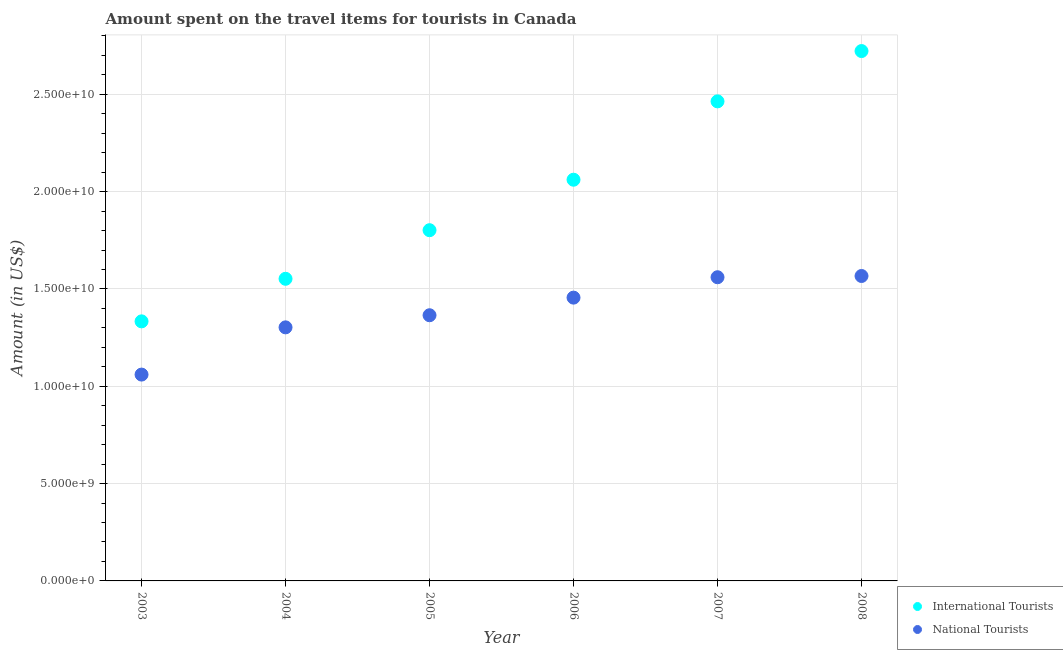How many different coloured dotlines are there?
Your response must be concise. 2. Is the number of dotlines equal to the number of legend labels?
Your answer should be very brief. Yes. What is the amount spent on travel items of national tourists in 2006?
Give a very brief answer. 1.46e+1. Across all years, what is the maximum amount spent on travel items of international tourists?
Your response must be concise. 2.72e+1. Across all years, what is the minimum amount spent on travel items of national tourists?
Your answer should be very brief. 1.06e+1. In which year was the amount spent on travel items of national tourists maximum?
Your response must be concise. 2008. What is the total amount spent on travel items of national tourists in the graph?
Offer a very short reply. 8.31e+1. What is the difference between the amount spent on travel items of national tourists in 2003 and that in 2008?
Offer a terse response. -5.07e+09. What is the difference between the amount spent on travel items of international tourists in 2007 and the amount spent on travel items of national tourists in 2008?
Give a very brief answer. 8.97e+09. What is the average amount spent on travel items of international tourists per year?
Offer a terse response. 1.99e+1. In the year 2003, what is the difference between the amount spent on travel items of national tourists and amount spent on travel items of international tourists?
Ensure brevity in your answer.  -2.74e+09. What is the ratio of the amount spent on travel items of international tourists in 2005 to that in 2006?
Your response must be concise. 0.87. Is the amount spent on travel items of national tourists in 2006 less than that in 2007?
Offer a terse response. Yes. What is the difference between the highest and the second highest amount spent on travel items of national tourists?
Give a very brief answer. 6.40e+07. What is the difference between the highest and the lowest amount spent on travel items of international tourists?
Give a very brief answer. 1.39e+1. In how many years, is the amount spent on travel items of national tourists greater than the average amount spent on travel items of national tourists taken over all years?
Your response must be concise. 3. Is the sum of the amount spent on travel items of international tourists in 2005 and 2008 greater than the maximum amount spent on travel items of national tourists across all years?
Make the answer very short. Yes. Is the amount spent on travel items of national tourists strictly less than the amount spent on travel items of international tourists over the years?
Give a very brief answer. Yes. How many years are there in the graph?
Make the answer very short. 6. Where does the legend appear in the graph?
Ensure brevity in your answer.  Bottom right. How many legend labels are there?
Your answer should be very brief. 2. What is the title of the graph?
Provide a short and direct response. Amount spent on the travel items for tourists in Canada. What is the Amount (in US$) in International Tourists in 2003?
Provide a succinct answer. 1.33e+1. What is the Amount (in US$) of National Tourists in 2003?
Offer a terse response. 1.06e+1. What is the Amount (in US$) in International Tourists in 2004?
Give a very brief answer. 1.55e+1. What is the Amount (in US$) in National Tourists in 2004?
Give a very brief answer. 1.30e+1. What is the Amount (in US$) in International Tourists in 2005?
Keep it short and to the point. 1.80e+1. What is the Amount (in US$) of National Tourists in 2005?
Provide a succinct answer. 1.37e+1. What is the Amount (in US$) in International Tourists in 2006?
Provide a succinct answer. 2.06e+1. What is the Amount (in US$) in National Tourists in 2006?
Your answer should be compact. 1.46e+1. What is the Amount (in US$) in International Tourists in 2007?
Your answer should be very brief. 2.46e+1. What is the Amount (in US$) in National Tourists in 2007?
Ensure brevity in your answer.  1.56e+1. What is the Amount (in US$) in International Tourists in 2008?
Your answer should be very brief. 2.72e+1. What is the Amount (in US$) in National Tourists in 2008?
Make the answer very short. 1.57e+1. Across all years, what is the maximum Amount (in US$) in International Tourists?
Provide a short and direct response. 2.72e+1. Across all years, what is the maximum Amount (in US$) in National Tourists?
Give a very brief answer. 1.57e+1. Across all years, what is the minimum Amount (in US$) of International Tourists?
Ensure brevity in your answer.  1.33e+1. Across all years, what is the minimum Amount (in US$) of National Tourists?
Provide a short and direct response. 1.06e+1. What is the total Amount (in US$) of International Tourists in the graph?
Keep it short and to the point. 1.19e+11. What is the total Amount (in US$) of National Tourists in the graph?
Your answer should be compact. 8.31e+1. What is the difference between the Amount (in US$) of International Tourists in 2003 and that in 2004?
Ensure brevity in your answer.  -2.19e+09. What is the difference between the Amount (in US$) of National Tourists in 2003 and that in 2004?
Provide a short and direct response. -2.43e+09. What is the difference between the Amount (in US$) in International Tourists in 2003 and that in 2005?
Your answer should be very brief. -4.68e+09. What is the difference between the Amount (in US$) in National Tourists in 2003 and that in 2005?
Make the answer very short. -3.05e+09. What is the difference between the Amount (in US$) in International Tourists in 2003 and that in 2006?
Offer a very short reply. -7.28e+09. What is the difference between the Amount (in US$) in National Tourists in 2003 and that in 2006?
Offer a very short reply. -3.95e+09. What is the difference between the Amount (in US$) in International Tourists in 2003 and that in 2007?
Offer a very short reply. -1.13e+1. What is the difference between the Amount (in US$) in National Tourists in 2003 and that in 2007?
Offer a terse response. -5.00e+09. What is the difference between the Amount (in US$) in International Tourists in 2003 and that in 2008?
Offer a terse response. -1.39e+1. What is the difference between the Amount (in US$) of National Tourists in 2003 and that in 2008?
Your response must be concise. -5.07e+09. What is the difference between the Amount (in US$) of International Tourists in 2004 and that in 2005?
Your response must be concise. -2.50e+09. What is the difference between the Amount (in US$) in National Tourists in 2004 and that in 2005?
Your response must be concise. -6.22e+08. What is the difference between the Amount (in US$) of International Tourists in 2004 and that in 2006?
Ensure brevity in your answer.  -5.09e+09. What is the difference between the Amount (in US$) in National Tourists in 2004 and that in 2006?
Keep it short and to the point. -1.53e+09. What is the difference between the Amount (in US$) in International Tourists in 2004 and that in 2007?
Your answer should be compact. -9.12e+09. What is the difference between the Amount (in US$) of National Tourists in 2004 and that in 2007?
Your answer should be very brief. -2.58e+09. What is the difference between the Amount (in US$) in International Tourists in 2004 and that in 2008?
Your answer should be very brief. -1.17e+1. What is the difference between the Amount (in US$) in National Tourists in 2004 and that in 2008?
Provide a succinct answer. -2.64e+09. What is the difference between the Amount (in US$) of International Tourists in 2005 and that in 2006?
Your response must be concise. -2.59e+09. What is the difference between the Amount (in US$) in National Tourists in 2005 and that in 2006?
Offer a terse response. -9.05e+08. What is the difference between the Amount (in US$) of International Tourists in 2005 and that in 2007?
Provide a succinct answer. -6.62e+09. What is the difference between the Amount (in US$) of National Tourists in 2005 and that in 2007?
Provide a short and direct response. -1.95e+09. What is the difference between the Amount (in US$) in International Tourists in 2005 and that in 2008?
Offer a very short reply. -9.20e+09. What is the difference between the Amount (in US$) in National Tourists in 2005 and that in 2008?
Your answer should be very brief. -2.02e+09. What is the difference between the Amount (in US$) of International Tourists in 2006 and that in 2007?
Your answer should be very brief. -4.03e+09. What is the difference between the Amount (in US$) of National Tourists in 2006 and that in 2007?
Your answer should be very brief. -1.05e+09. What is the difference between the Amount (in US$) of International Tourists in 2006 and that in 2008?
Your answer should be compact. -6.61e+09. What is the difference between the Amount (in US$) in National Tourists in 2006 and that in 2008?
Your answer should be compact. -1.11e+09. What is the difference between the Amount (in US$) in International Tourists in 2007 and that in 2008?
Offer a very short reply. -2.58e+09. What is the difference between the Amount (in US$) of National Tourists in 2007 and that in 2008?
Provide a short and direct response. -6.40e+07. What is the difference between the Amount (in US$) in International Tourists in 2003 and the Amount (in US$) in National Tourists in 2004?
Offer a very short reply. 3.08e+08. What is the difference between the Amount (in US$) in International Tourists in 2003 and the Amount (in US$) in National Tourists in 2005?
Provide a short and direct response. -3.14e+08. What is the difference between the Amount (in US$) in International Tourists in 2003 and the Amount (in US$) in National Tourists in 2006?
Offer a very short reply. -1.22e+09. What is the difference between the Amount (in US$) in International Tourists in 2003 and the Amount (in US$) in National Tourists in 2007?
Offer a terse response. -2.27e+09. What is the difference between the Amount (in US$) of International Tourists in 2003 and the Amount (in US$) of National Tourists in 2008?
Offer a terse response. -2.33e+09. What is the difference between the Amount (in US$) of International Tourists in 2004 and the Amount (in US$) of National Tourists in 2005?
Your answer should be very brief. 1.87e+09. What is the difference between the Amount (in US$) of International Tourists in 2004 and the Amount (in US$) of National Tourists in 2006?
Your response must be concise. 9.68e+08. What is the difference between the Amount (in US$) in International Tourists in 2004 and the Amount (in US$) in National Tourists in 2007?
Keep it short and to the point. -8.00e+07. What is the difference between the Amount (in US$) of International Tourists in 2004 and the Amount (in US$) of National Tourists in 2008?
Keep it short and to the point. -1.44e+08. What is the difference between the Amount (in US$) of International Tourists in 2005 and the Amount (in US$) of National Tourists in 2006?
Make the answer very short. 3.46e+09. What is the difference between the Amount (in US$) of International Tourists in 2005 and the Amount (in US$) of National Tourists in 2007?
Make the answer very short. 2.42e+09. What is the difference between the Amount (in US$) in International Tourists in 2005 and the Amount (in US$) in National Tourists in 2008?
Ensure brevity in your answer.  2.35e+09. What is the difference between the Amount (in US$) in International Tourists in 2006 and the Amount (in US$) in National Tourists in 2007?
Provide a succinct answer. 5.01e+09. What is the difference between the Amount (in US$) of International Tourists in 2006 and the Amount (in US$) of National Tourists in 2008?
Ensure brevity in your answer.  4.95e+09. What is the difference between the Amount (in US$) in International Tourists in 2007 and the Amount (in US$) in National Tourists in 2008?
Ensure brevity in your answer.  8.97e+09. What is the average Amount (in US$) of International Tourists per year?
Give a very brief answer. 1.99e+1. What is the average Amount (in US$) in National Tourists per year?
Your answer should be very brief. 1.39e+1. In the year 2003, what is the difference between the Amount (in US$) of International Tourists and Amount (in US$) of National Tourists?
Offer a very short reply. 2.74e+09. In the year 2004, what is the difference between the Amount (in US$) of International Tourists and Amount (in US$) of National Tourists?
Your response must be concise. 2.50e+09. In the year 2005, what is the difference between the Amount (in US$) in International Tourists and Amount (in US$) in National Tourists?
Provide a succinct answer. 4.37e+09. In the year 2006, what is the difference between the Amount (in US$) of International Tourists and Amount (in US$) of National Tourists?
Offer a terse response. 6.06e+09. In the year 2007, what is the difference between the Amount (in US$) in International Tourists and Amount (in US$) in National Tourists?
Your answer should be compact. 9.04e+09. In the year 2008, what is the difference between the Amount (in US$) in International Tourists and Amount (in US$) in National Tourists?
Make the answer very short. 1.16e+1. What is the ratio of the Amount (in US$) of International Tourists in 2003 to that in 2004?
Offer a terse response. 0.86. What is the ratio of the Amount (in US$) in National Tourists in 2003 to that in 2004?
Offer a very short reply. 0.81. What is the ratio of the Amount (in US$) in International Tourists in 2003 to that in 2005?
Keep it short and to the point. 0.74. What is the ratio of the Amount (in US$) of National Tourists in 2003 to that in 2005?
Your response must be concise. 0.78. What is the ratio of the Amount (in US$) in International Tourists in 2003 to that in 2006?
Keep it short and to the point. 0.65. What is the ratio of the Amount (in US$) of National Tourists in 2003 to that in 2006?
Make the answer very short. 0.73. What is the ratio of the Amount (in US$) in International Tourists in 2003 to that in 2007?
Keep it short and to the point. 0.54. What is the ratio of the Amount (in US$) in National Tourists in 2003 to that in 2007?
Your response must be concise. 0.68. What is the ratio of the Amount (in US$) of International Tourists in 2003 to that in 2008?
Offer a terse response. 0.49. What is the ratio of the Amount (in US$) of National Tourists in 2003 to that in 2008?
Offer a very short reply. 0.68. What is the ratio of the Amount (in US$) of International Tourists in 2004 to that in 2005?
Ensure brevity in your answer.  0.86. What is the ratio of the Amount (in US$) of National Tourists in 2004 to that in 2005?
Your response must be concise. 0.95. What is the ratio of the Amount (in US$) in International Tourists in 2004 to that in 2006?
Give a very brief answer. 0.75. What is the ratio of the Amount (in US$) of National Tourists in 2004 to that in 2006?
Your answer should be very brief. 0.9. What is the ratio of the Amount (in US$) in International Tourists in 2004 to that in 2007?
Offer a terse response. 0.63. What is the ratio of the Amount (in US$) in National Tourists in 2004 to that in 2007?
Provide a short and direct response. 0.83. What is the ratio of the Amount (in US$) of International Tourists in 2004 to that in 2008?
Give a very brief answer. 0.57. What is the ratio of the Amount (in US$) of National Tourists in 2004 to that in 2008?
Your answer should be compact. 0.83. What is the ratio of the Amount (in US$) in International Tourists in 2005 to that in 2006?
Make the answer very short. 0.87. What is the ratio of the Amount (in US$) of National Tourists in 2005 to that in 2006?
Ensure brevity in your answer.  0.94. What is the ratio of the Amount (in US$) in International Tourists in 2005 to that in 2007?
Your answer should be compact. 0.73. What is the ratio of the Amount (in US$) of National Tourists in 2005 to that in 2007?
Provide a short and direct response. 0.87. What is the ratio of the Amount (in US$) of International Tourists in 2005 to that in 2008?
Offer a very short reply. 0.66. What is the ratio of the Amount (in US$) in National Tourists in 2005 to that in 2008?
Offer a very short reply. 0.87. What is the ratio of the Amount (in US$) of International Tourists in 2006 to that in 2007?
Keep it short and to the point. 0.84. What is the ratio of the Amount (in US$) in National Tourists in 2006 to that in 2007?
Give a very brief answer. 0.93. What is the ratio of the Amount (in US$) in International Tourists in 2006 to that in 2008?
Your answer should be very brief. 0.76. What is the ratio of the Amount (in US$) of National Tourists in 2006 to that in 2008?
Offer a very short reply. 0.93. What is the ratio of the Amount (in US$) of International Tourists in 2007 to that in 2008?
Your response must be concise. 0.91. What is the difference between the highest and the second highest Amount (in US$) of International Tourists?
Offer a very short reply. 2.58e+09. What is the difference between the highest and the second highest Amount (in US$) in National Tourists?
Your answer should be very brief. 6.40e+07. What is the difference between the highest and the lowest Amount (in US$) of International Tourists?
Provide a short and direct response. 1.39e+1. What is the difference between the highest and the lowest Amount (in US$) of National Tourists?
Your answer should be compact. 5.07e+09. 